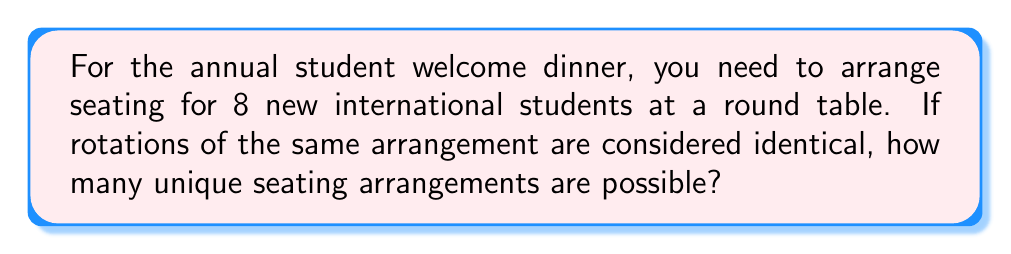Can you solve this math problem? Let's approach this step-by-step:

1) First, we need to recognize that this is a circular permutation problem. In a circular arrangement, rotations of the same arrangement are considered identical.

2) For a linear arrangement of n distinct objects, we would have n! permutations.

3) However, for a circular arrangement, we divide by n because n rotations of each arrangement are considered the same. This gives us (n-1)! unique arrangements.

4) In this case, we have 8 students, so n = 8.

5) Therefore, the number of unique seating arrangements is:

   $$(8-1)! = 7!$$

6) Let's calculate this:
   
   $$7! = 7 \times 6 \times 5 \times 4 \times 3 \times 2 \times 1 = 5040$$

Thus, there are 5040 unique seating arrangements for the 8 international students at the round table.
Answer: 5040 unique seating arrangements 